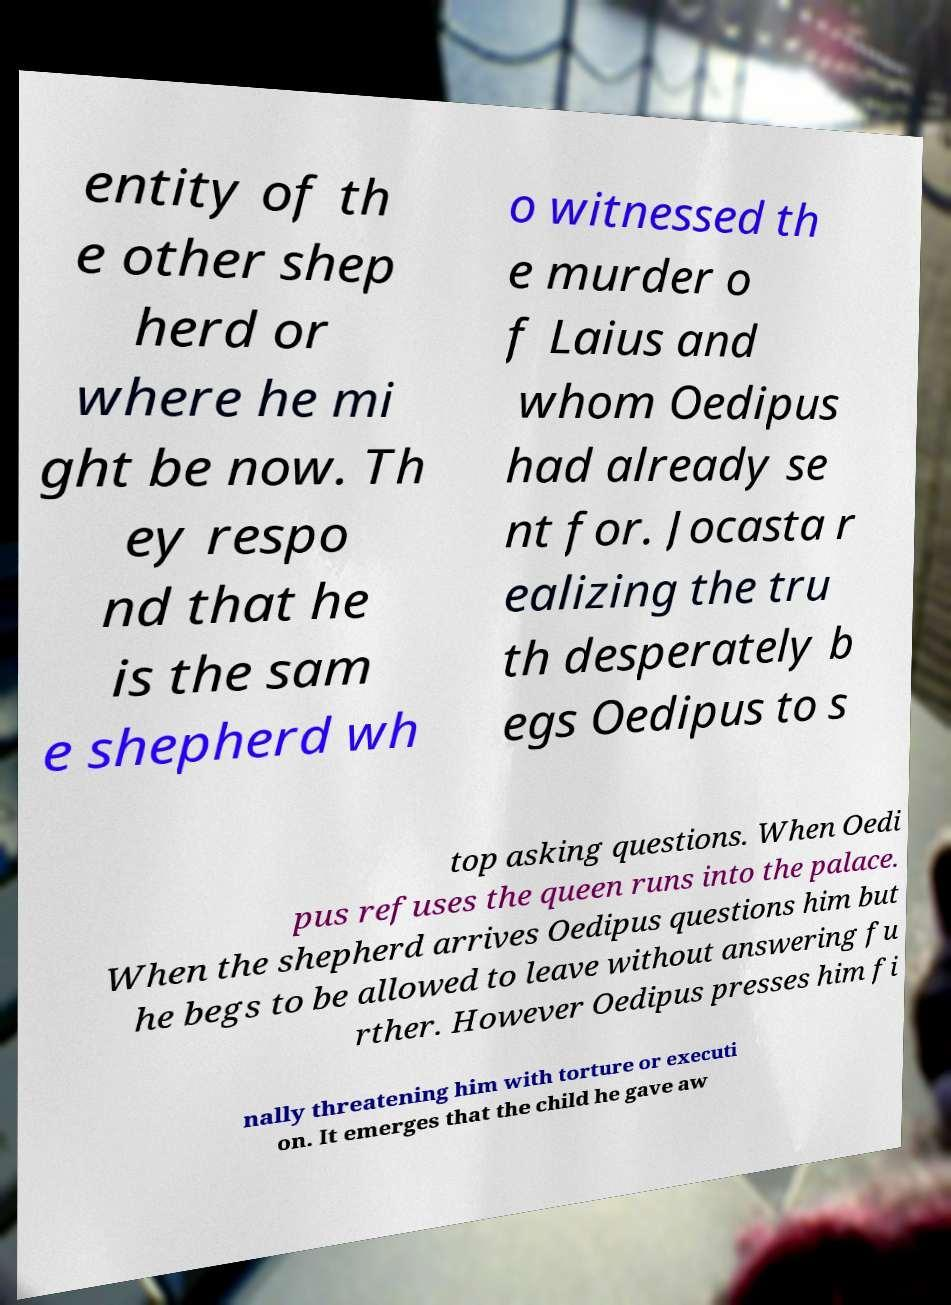For documentation purposes, I need the text within this image transcribed. Could you provide that? entity of th e other shep herd or where he mi ght be now. Th ey respo nd that he is the sam e shepherd wh o witnessed th e murder o f Laius and whom Oedipus had already se nt for. Jocasta r ealizing the tru th desperately b egs Oedipus to s top asking questions. When Oedi pus refuses the queen runs into the palace. When the shepherd arrives Oedipus questions him but he begs to be allowed to leave without answering fu rther. However Oedipus presses him fi nally threatening him with torture or executi on. It emerges that the child he gave aw 